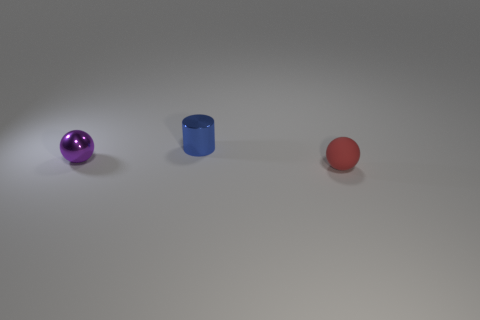Add 3 tiny purple shiny things. How many objects exist? 6 Subtract 1 balls. How many balls are left? 1 Subtract all balls. How many objects are left? 1 Subtract all purple balls. How many balls are left? 1 Subtract all big gray metallic objects. Subtract all small blue shiny cylinders. How many objects are left? 2 Add 2 small purple metallic balls. How many small purple metallic balls are left? 3 Add 1 tiny purple shiny balls. How many tiny purple shiny balls exist? 2 Subtract 0 blue cubes. How many objects are left? 3 Subtract all cyan cylinders. Subtract all cyan blocks. How many cylinders are left? 1 